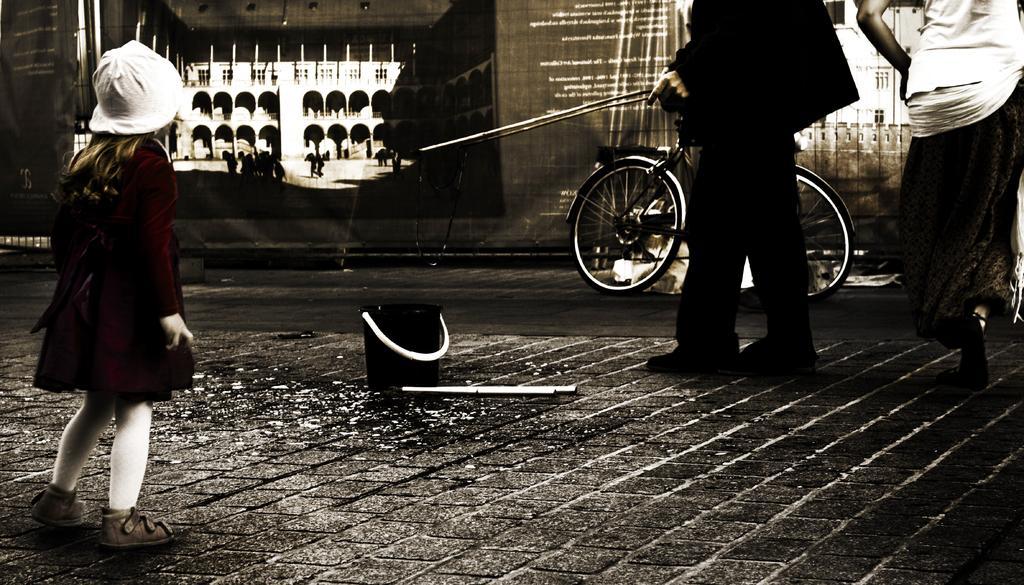In one or two sentences, can you explain what this image depicts? In this image, we can see persons wearing clothes. There is a cycle beside the banner. There is a bucket and stick in the middle of the image. 